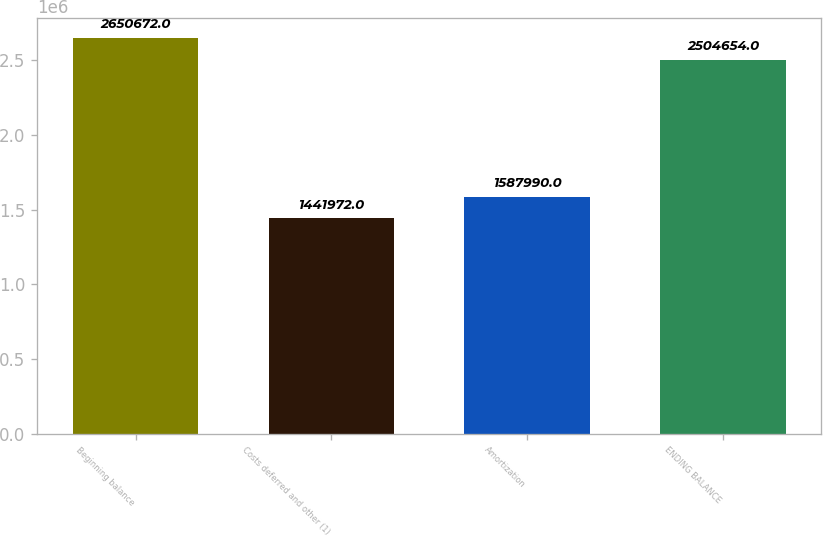Convert chart. <chart><loc_0><loc_0><loc_500><loc_500><bar_chart><fcel>Beginning balance<fcel>Costs deferred and other (1)<fcel>Amortization<fcel>ENDING BALANCE<nl><fcel>2.65067e+06<fcel>1.44197e+06<fcel>1.58799e+06<fcel>2.50465e+06<nl></chart> 